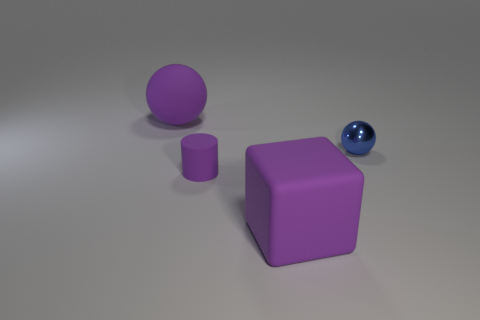Add 3 brown metal spheres. How many objects exist? 7 Subtract all cubes. How many objects are left? 3 Subtract all purple cylinders. Subtract all big purple balls. How many objects are left? 2 Add 2 tiny purple matte cylinders. How many tiny purple matte cylinders are left? 3 Add 2 small blue objects. How many small blue objects exist? 3 Subtract 0 green cubes. How many objects are left? 4 